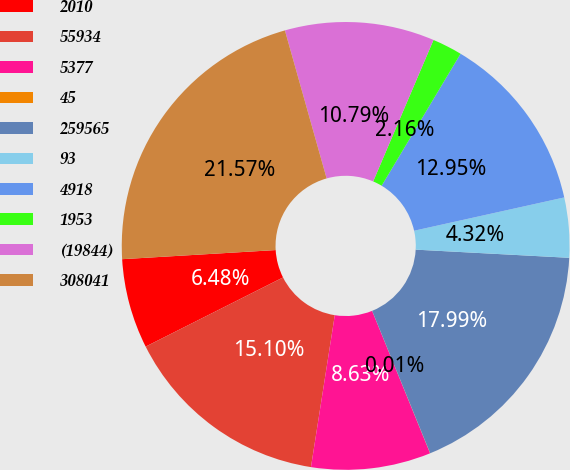Convert chart to OTSL. <chart><loc_0><loc_0><loc_500><loc_500><pie_chart><fcel>2010<fcel>55934<fcel>5377<fcel>45<fcel>259565<fcel>93<fcel>4918<fcel>1953<fcel>(19844)<fcel>308041<nl><fcel>6.48%<fcel>15.1%<fcel>8.63%<fcel>0.01%<fcel>17.99%<fcel>4.32%<fcel>12.95%<fcel>2.16%<fcel>10.79%<fcel>21.57%<nl></chart> 